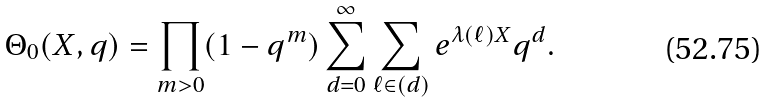<formula> <loc_0><loc_0><loc_500><loc_500>\Theta _ { 0 } ( X , q ) = \prod _ { m > 0 } ( 1 - q ^ { m } ) \sum _ { d = 0 } ^ { \infty } \sum _ { \ell \in ( d ) } e ^ { \lambda ( \ell ) X } q ^ { d } .</formula> 